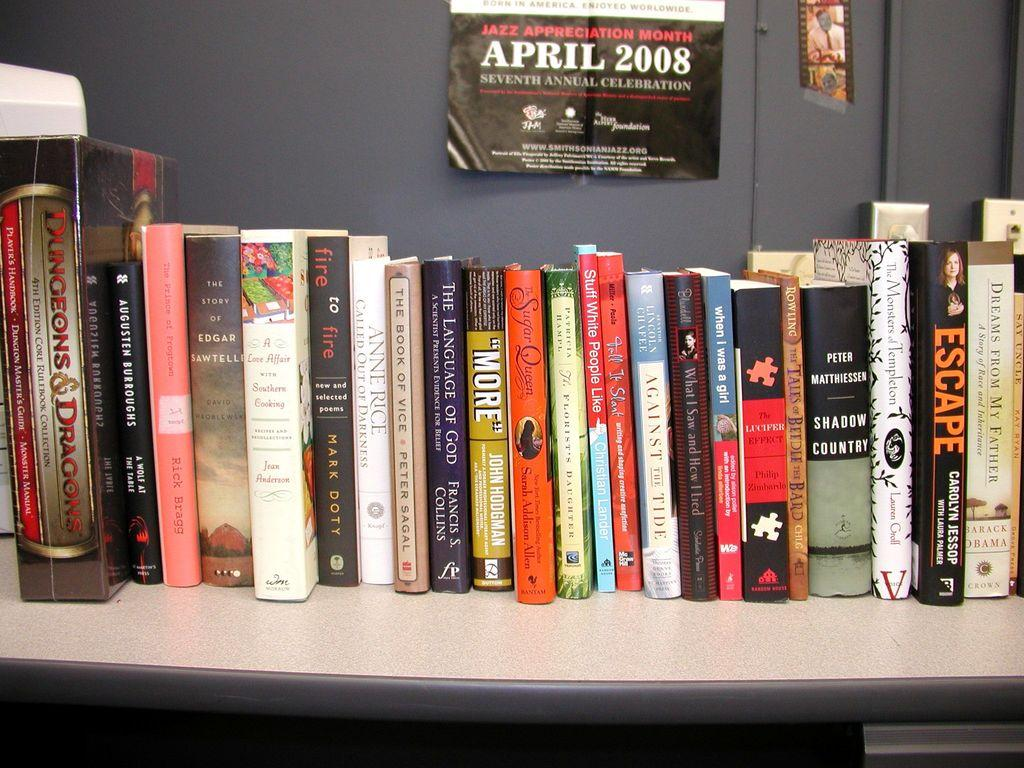<image>
Create a compact narrative representing the image presented. A bookshelf with a poster advertising the Seventh Annual Jazz Appreciation Month for April 2008. 